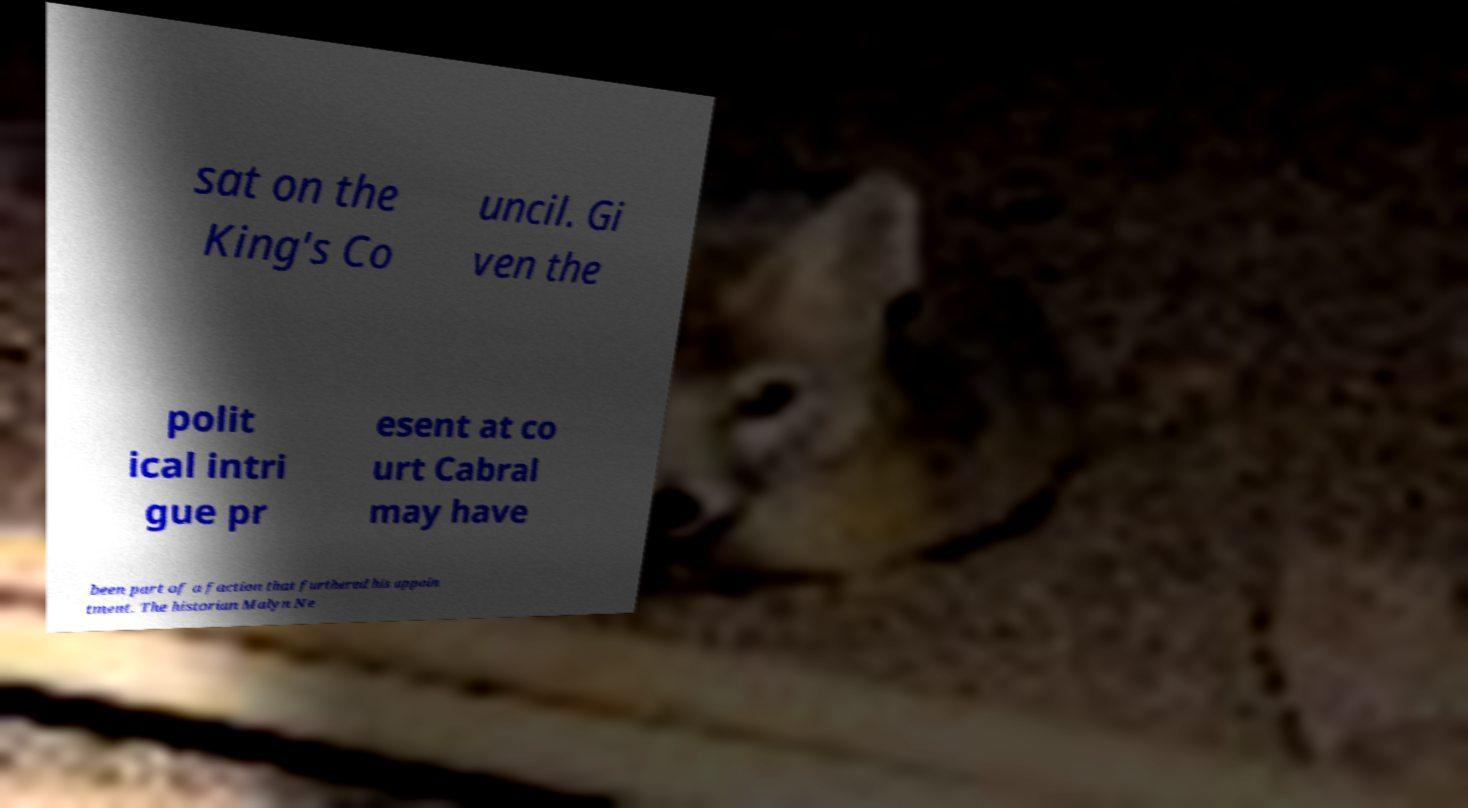There's text embedded in this image that I need extracted. Can you transcribe it verbatim? sat on the King's Co uncil. Gi ven the polit ical intri gue pr esent at co urt Cabral may have been part of a faction that furthered his appoin tment. The historian Malyn Ne 